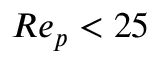Convert formula to latex. <formula><loc_0><loc_0><loc_500><loc_500>R e _ { p } < 2 5</formula> 